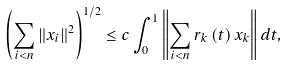<formula> <loc_0><loc_0><loc_500><loc_500>\left ( \sum _ { i < n } \left \| x _ { i } \right \| ^ { 2 } \right ) ^ { 1 / 2 } \leq c \int _ { 0 } ^ { 1 } \left \| \sum _ { i < n } r _ { k } \left ( t \right ) x _ { k } \right \| d t ,</formula> 